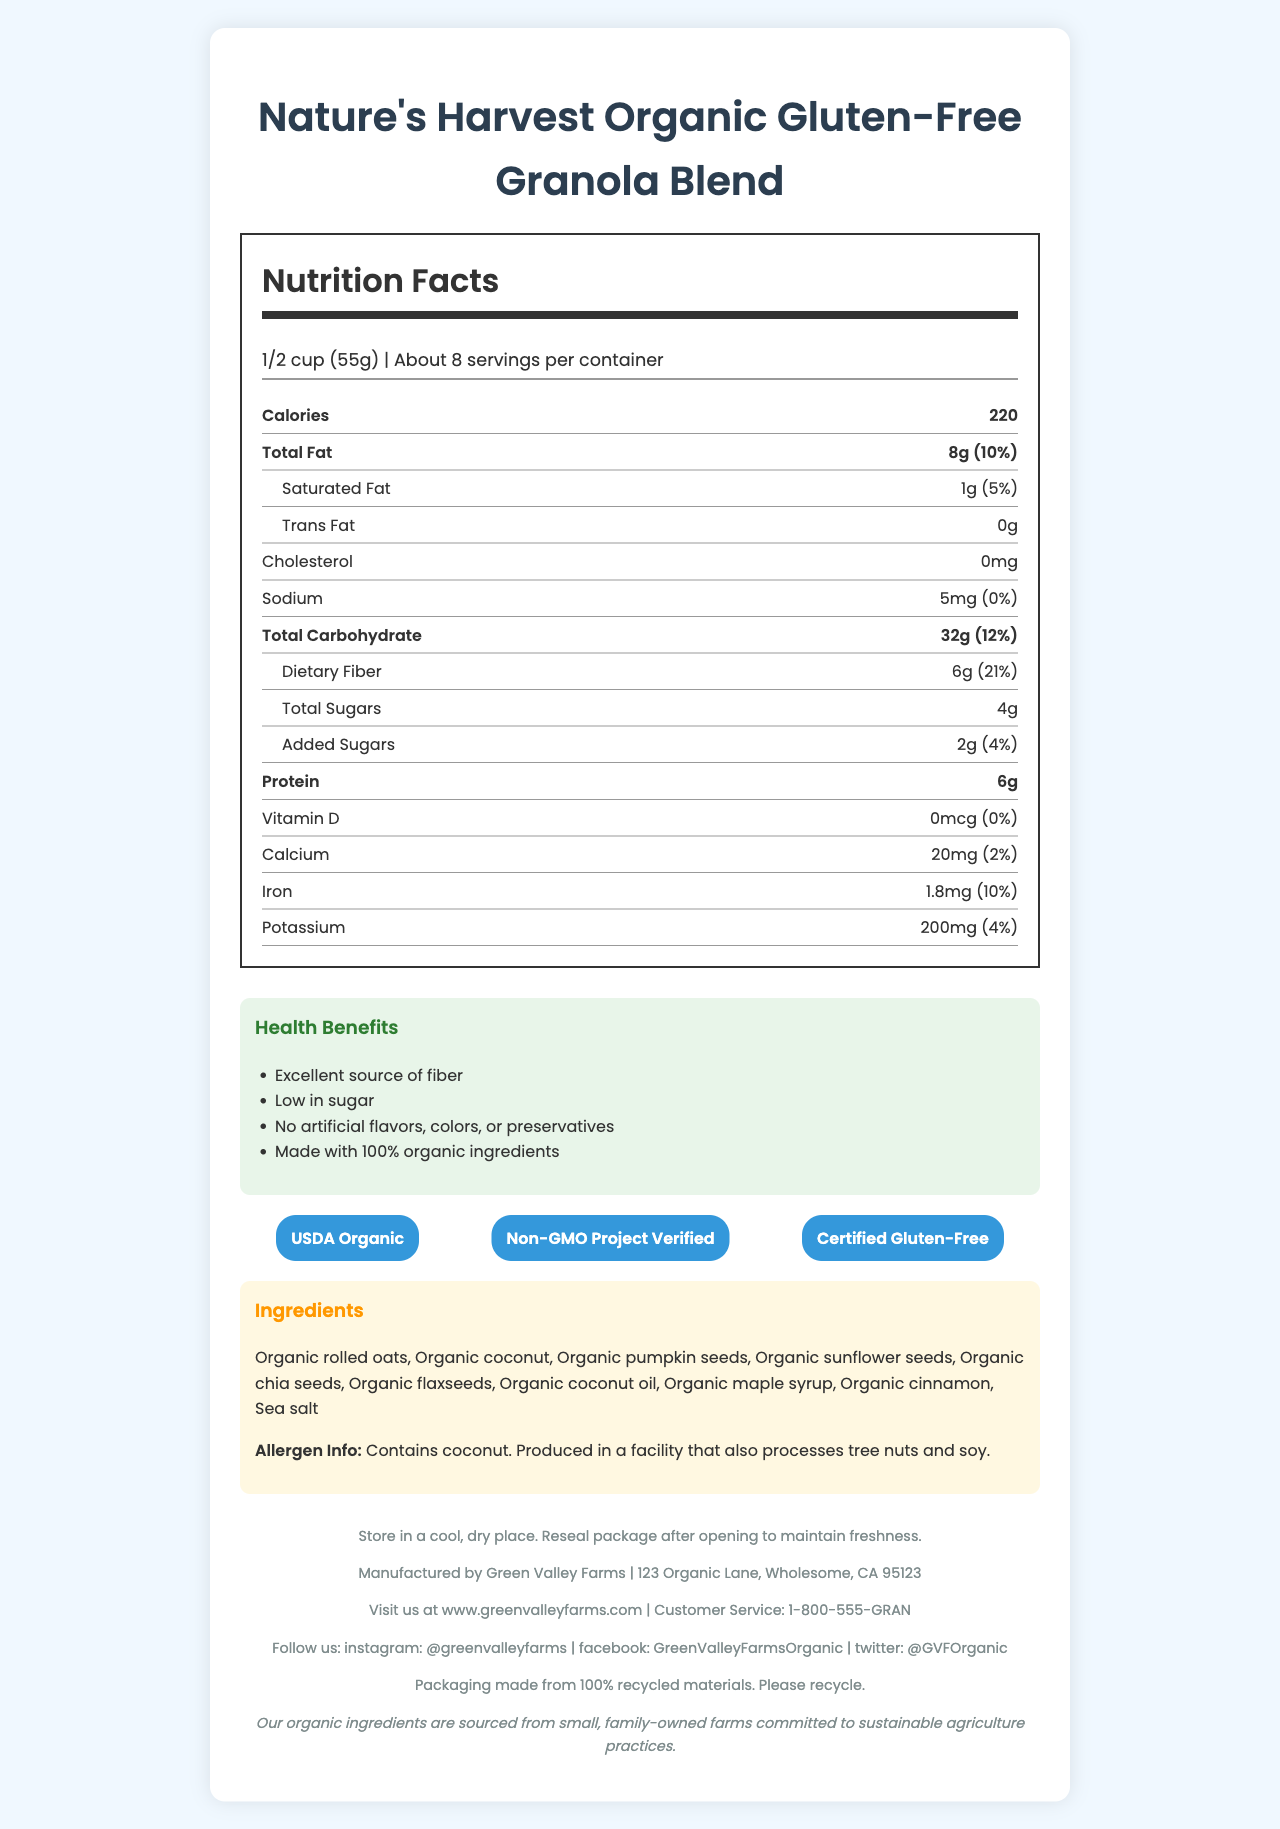what is the serving size for Nature's Harvest Organic Gluten-Free Granola Blend? The serving size is listed as "1/2 cup (55g)" under the Nutrition Facts label.
Answer: 1/2 cup (55g) how many servings per container are there? The label states that there are "About 8" servings per container.
Answer: About 8 what are the total calories per serving? The total calories per serving is mentioned as "220" next to the serving size information.
Answer: 220 calories how much dietary fiber is there in one serving? The label specifies "6g" for dietary fiber under Total Carbohydrate.
Answer: 6g what is the daily value percentage of dietary fiber per serving? The daily value percentage for dietary fiber is given as "21%" under Total Carbohydrate.
Answer: 21% how many total sugars are in one serving of the granola blend? The total sugars per serving are listed as "4g" under Total Carbohydrate.
Answer: 4g are there any added sugars in the granola blend? The document lists "2g" of added sugars along with a daily value of "4%" under the Total Carbohydrate section.
Answer: Yes what are the main ingredients in the Nature's Harvest Organic Gluten-Free Granola Blend? These ingredients are listed under the "Ingredients" section.
Answer: Organic rolled oats, Organic coconut, Organic pumpkin seeds, Organic sunflower seeds, Organic chia seeds, Organic flaxseeds, Organic coconut oil, Organic maple syrup, Organic cinnamon, Sea salt what percentage of daily value of iron is in one serving? The daily value percentage for iron is noted as "10%" under Iron in the nutrition breakdown.
Answer: 10% what types of certifications does this product have? The certifications are listed under the "Certifications" section.
Answer: USDA Organic, Non-GMO Project Verified, Certified Gluten-Free Which of the following are NOT included in the granola blend's health claims? (A) Made with 100% organic ingredients (B) Excellent source of protein (C) Low in sugar (D) No artificial flavors, colors, or preservatives "Excellent source of protein" is not listed among the health claims. The actual claims are "Made with 100% organic ingredients," "Low in sugar," "No artificial flavors, colors, or preservatives," and "Excellent source of fiber."
Answer: B where should you store this granola blend? (A) In a refrigerator (B) In a cool, dry place (C) At room temperature (D) In a freezer The storage instructions indicate that the product should be stored "in a cool, dry place."
Answer: B does this product contain any allergens? The allergen information states that the product "Contains coconut" and is produced in a facility that also processes tree nuts and soy.
Answer: Yes is the granola blend high in fiber? The health claims section explicitly states that it is an "Excellent source of fiber," and the dietary fiber content is 6g per serving with a daily value of 21%.
Answer: Yes describe the main idea of this document The document content includes comprehensive nutrition facts, ingredients, health claims, certifications, storage instructions, and manufacturer details, presenting Nature's Harvest Organic Gluten-Free Granola Blend as a healthy, organic option.
Answer: This document provides detailed nutritional information and ingredients for Nature's Harvest Organic Gluten-Free Granola Blend. It highlights the product's nutritional benefits, such as being high in fiber and low in sugar, lists ingredients and allergens, and includes storage instructions, manufacturer details, certifications, and health claims. how much potassium is in one serving? The nutrition facts section lists potassium as "200mg" per serving alongside its daily value.
Answer: 200mg what is the address of the manufacturer? The manufacturer's address is provided under the footer with manufacturer details.
Answer: 123 Organic Lane, Wholesome, CA 95123 is there any information about the granola blend's sustainability? The sustainability information indicates that the packaging is made from "100% recycled materials" and encourages recycling.
Answer: Yes what is the source of vitamin D in this granola blend? The Nutrition Facts label lists Vitamin D as "0mcg" with a daily value of "0%," indicating no significant source of vitamin D.
Answer: Not available where are the organic ingredients sourced from? This information is found in the "farm to table story" section in the footer.
Answer: Small, family-owned farms committed to sustainable agriculture practices how much saturated fat is there in one serving? The amount of saturated fat per serving is listed as "1g" on the nutrition label.
Answer: 1g 